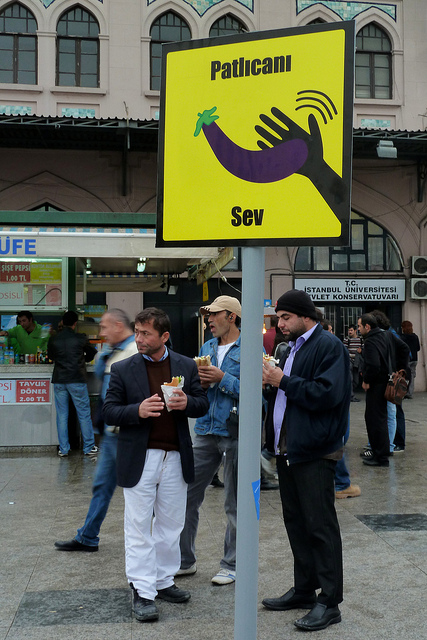Extract all visible text content from this image. Patlicani Sev UFE DONER TL SISLI TL KONSERVATUVARI UNIVERSITIES STANDUL T.C 